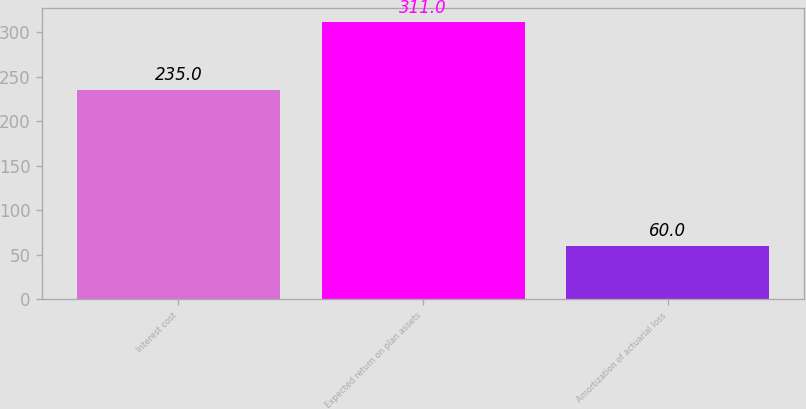Convert chart. <chart><loc_0><loc_0><loc_500><loc_500><bar_chart><fcel>Interest cost<fcel>Expected return on plan assets<fcel>Amortization of actuarial loss<nl><fcel>235<fcel>311<fcel>60<nl></chart> 